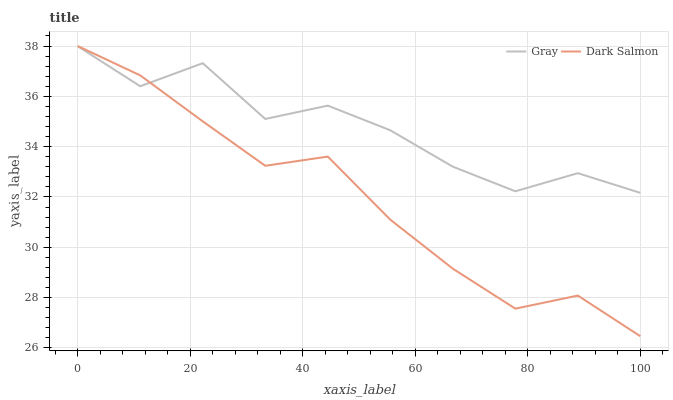Does Dark Salmon have the minimum area under the curve?
Answer yes or no. Yes. Does Gray have the maximum area under the curve?
Answer yes or no. Yes. Does Dark Salmon have the maximum area under the curve?
Answer yes or no. No. Is Dark Salmon the smoothest?
Answer yes or no. Yes. Is Gray the roughest?
Answer yes or no. Yes. Is Dark Salmon the roughest?
Answer yes or no. No. Does Dark Salmon have the highest value?
Answer yes or no. Yes. 